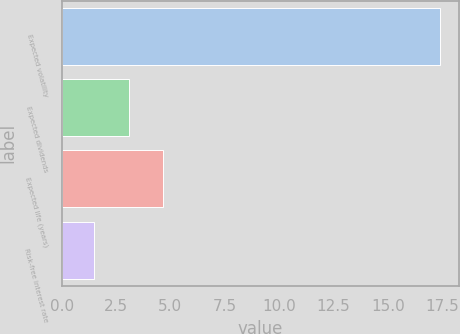<chart> <loc_0><loc_0><loc_500><loc_500><bar_chart><fcel>Expected volatility<fcel>Expected dividends<fcel>Expected life (years)<fcel>Risk-free interest rate<nl><fcel>17.4<fcel>3.09<fcel>4.68<fcel>1.5<nl></chart> 